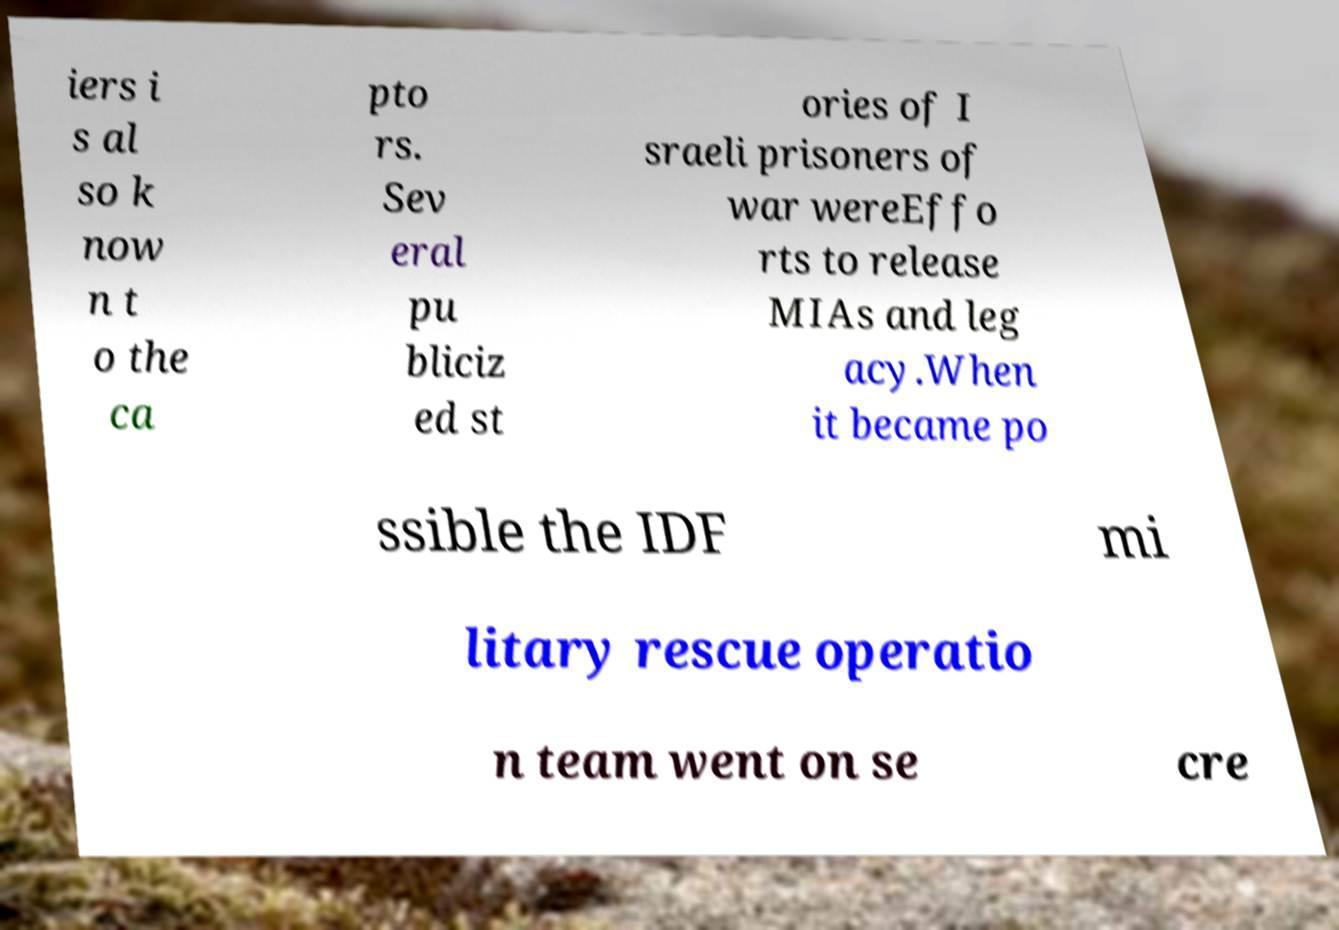For documentation purposes, I need the text within this image transcribed. Could you provide that? iers i s al so k now n t o the ca pto rs. Sev eral pu bliciz ed st ories of I sraeli prisoners of war wereEffo rts to release MIAs and leg acy.When it became po ssible the IDF mi litary rescue operatio n team went on se cre 